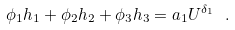<formula> <loc_0><loc_0><loc_500><loc_500>\phi _ { 1 } h _ { 1 } + \phi _ { 2 } h _ { 2 } + \phi _ { 3 } h _ { 3 } = a _ { 1 } U ^ { \delta _ { 1 } } \ .</formula> 